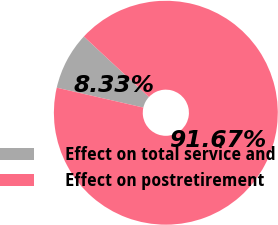<chart> <loc_0><loc_0><loc_500><loc_500><pie_chart><fcel>Effect on total service and<fcel>Effect on postretirement<nl><fcel>8.33%<fcel>91.67%<nl></chart> 